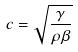Convert formula to latex. <formula><loc_0><loc_0><loc_500><loc_500>c = \sqrt { \frac { \gamma } { \rho \beta } }</formula> 